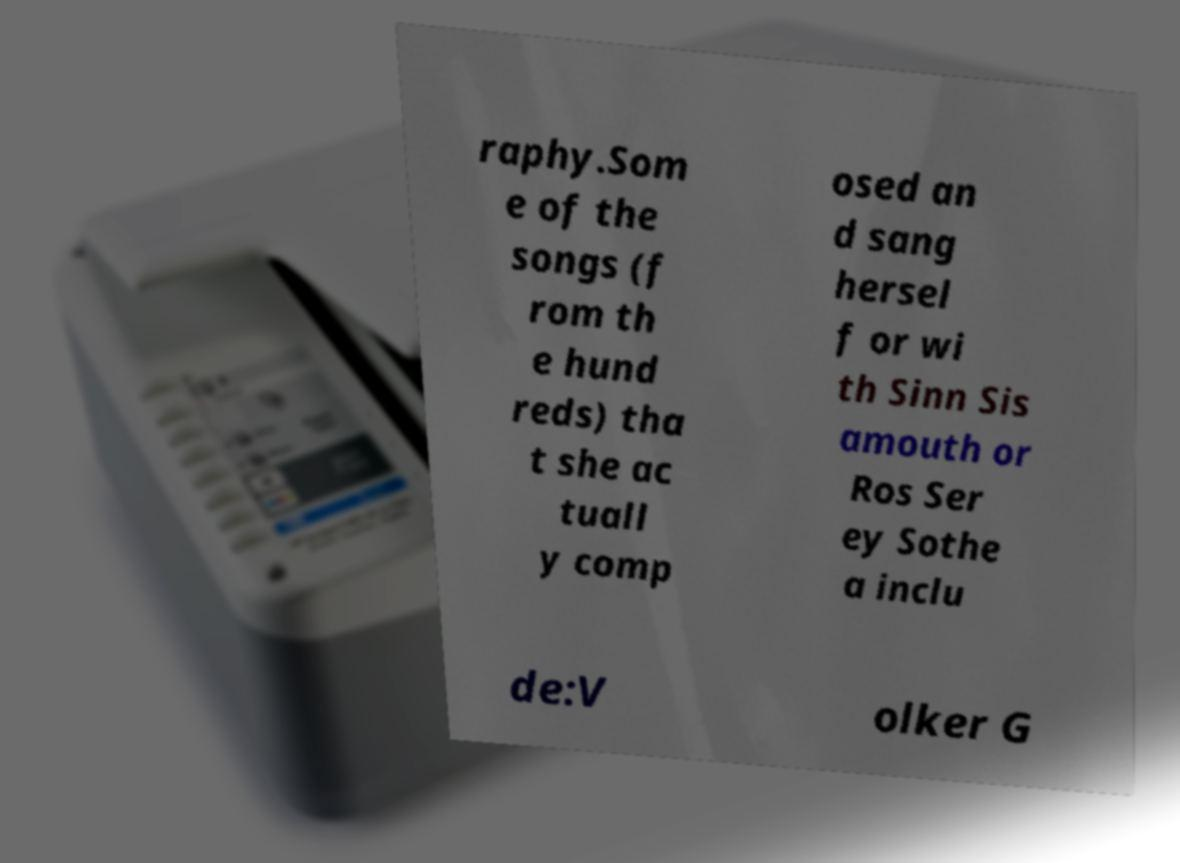There's text embedded in this image that I need extracted. Can you transcribe it verbatim? raphy.Som e of the songs (f rom th e hund reds) tha t she ac tuall y comp osed an d sang hersel f or wi th Sinn Sis amouth or Ros Ser ey Sothe a inclu de:V olker G 